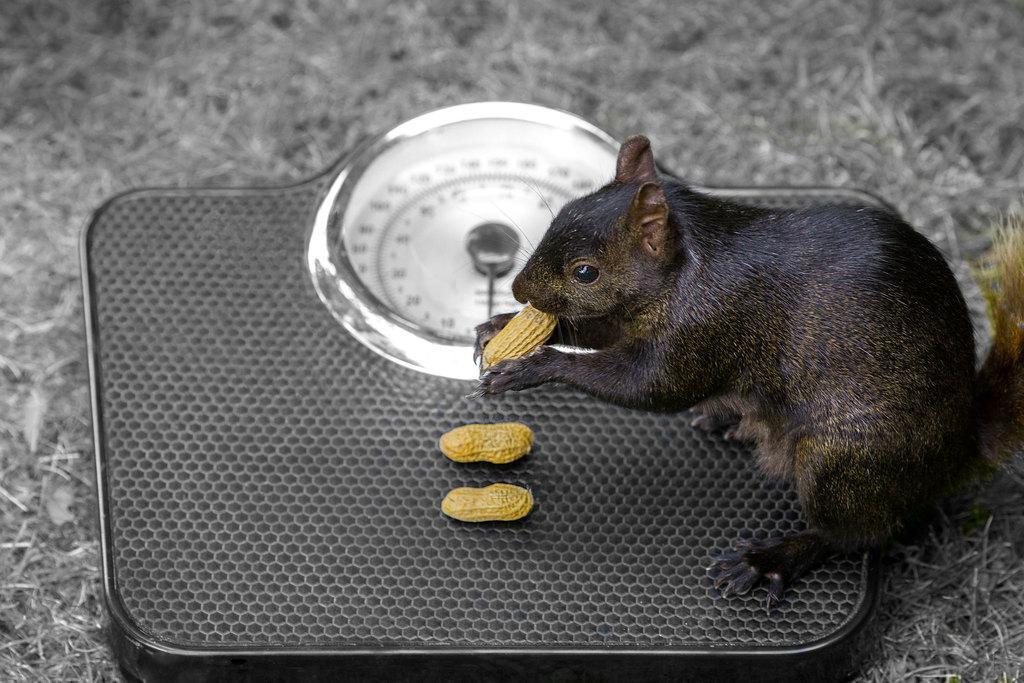Describe this image in one or two sentences. In this picture we can see a mouse holding a yellow object in the hands. We can see a few yellow objects on a weight scale machine. Some grass is visible on the ground. 